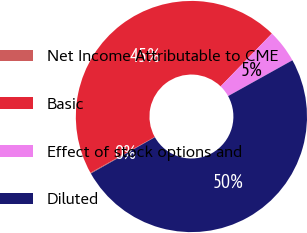Convert chart to OTSL. <chart><loc_0><loc_0><loc_500><loc_500><pie_chart><fcel>Net Income Attributable to CME<fcel>Basic<fcel>Effect of stock options and<fcel>Diluted<nl><fcel>0.12%<fcel>45.34%<fcel>4.66%<fcel>49.88%<nl></chart> 